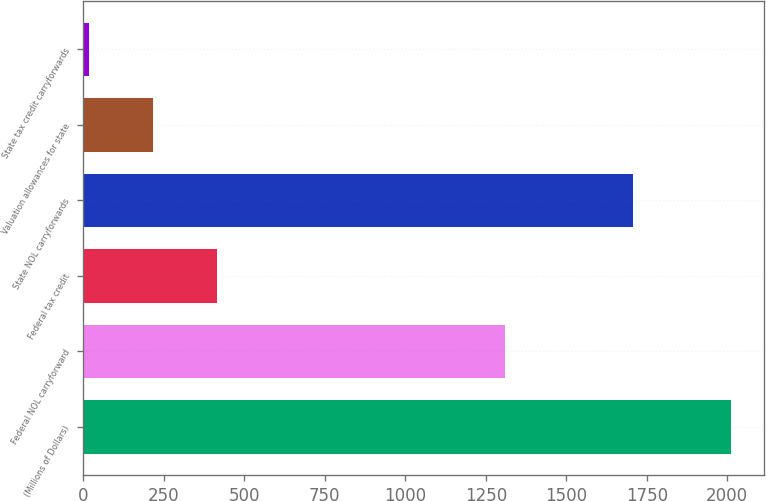<chart> <loc_0><loc_0><loc_500><loc_500><bar_chart><fcel>(Millions of Dollars)<fcel>Federal NOL carryforward<fcel>Federal tax credit<fcel>State NOL carryforwards<fcel>Valuation allowances for state<fcel>State tax credit carryforwards<nl><fcel>2013<fcel>1311<fcel>416.2<fcel>1706<fcel>216.6<fcel>17<nl></chart> 